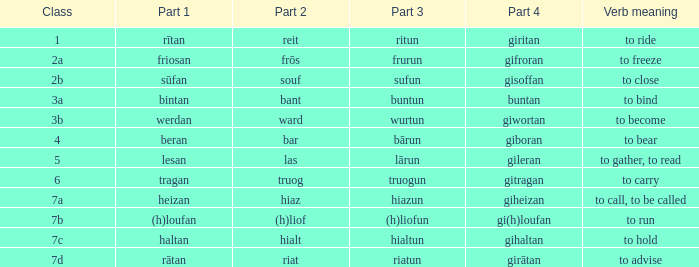What is the part 4 of the word with the part 1 "heizan"? Giheizan. 